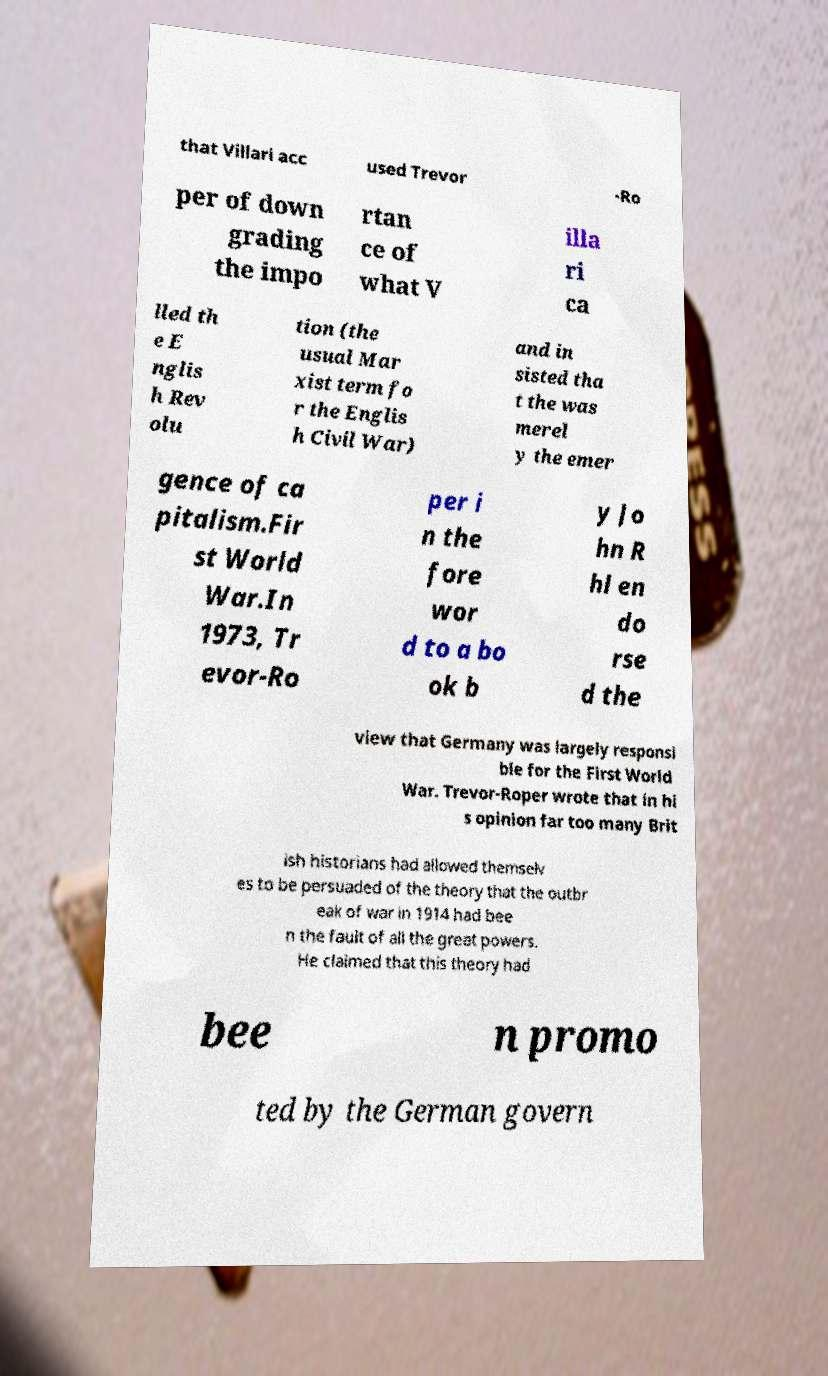For documentation purposes, I need the text within this image transcribed. Could you provide that? that Villari acc used Trevor -Ro per of down grading the impo rtan ce of what V illa ri ca lled th e E nglis h Rev olu tion (the usual Mar xist term fo r the Englis h Civil War) and in sisted tha t the was merel y the emer gence of ca pitalism.Fir st World War.In 1973, Tr evor-Ro per i n the fore wor d to a bo ok b y Jo hn R hl en do rse d the view that Germany was largely responsi ble for the First World War. Trevor-Roper wrote that in hi s opinion far too many Brit ish historians had allowed themselv es to be persuaded of the theory that the outbr eak of war in 1914 had bee n the fault of all the great powers. He claimed that this theory had bee n promo ted by the German govern 